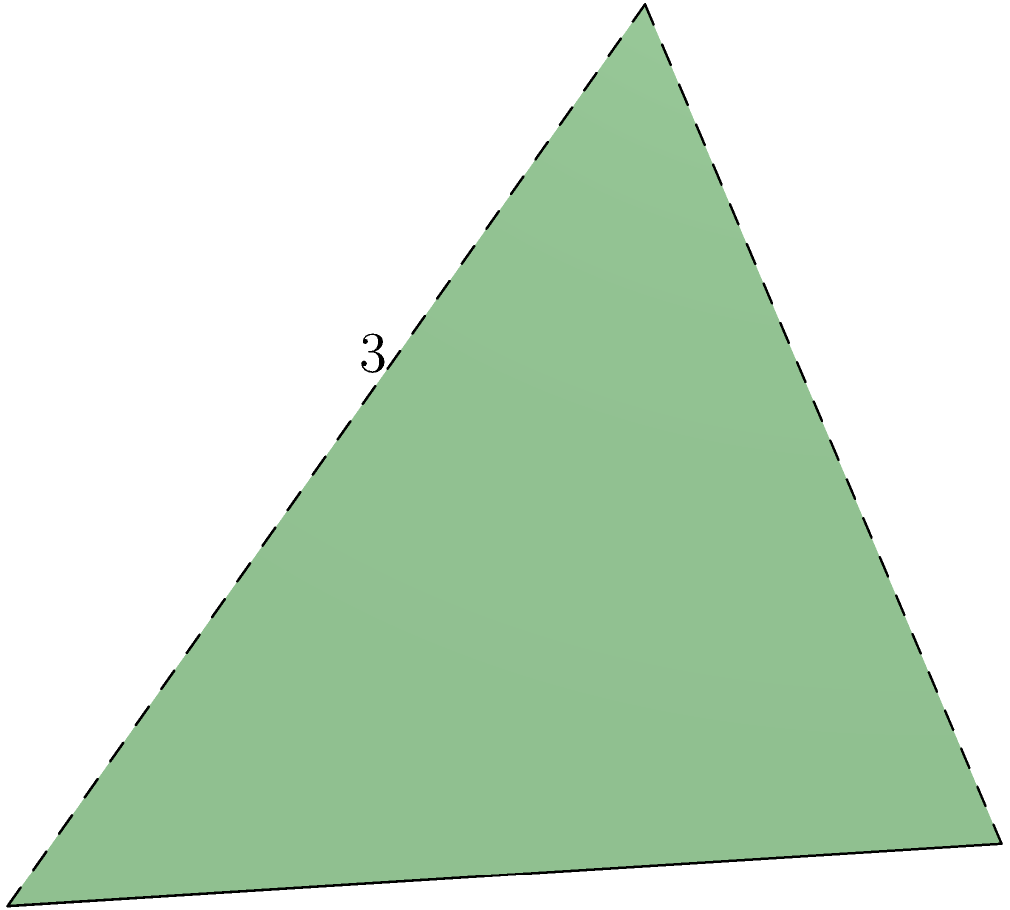You're exploring the wonders of ancient Egypt in your favorite strategy game when you come across a pyramid with a square base. The base measures 4 meters on each side, and the height of the pyramid is 3 meters. What is the volume of this pyramid? Let's approach this step-by-step:

1) The formula for the volume of a pyramid is:
   $$V = \frac{1}{3} \times B \times h$$
   where $V$ is volume, $B$ is the area of the base, and $h$ is the height.

2) We need to find the area of the base first. The base is a square with side length 4 meters:
   $$B = 4 \text{ m} \times 4 \text{ m} = 16 \text{ m}^2$$

3) Now we have all the information we need:
   - Base area $(B) = 16 \text{ m}^2$
   - Height $(h) = 3 \text{ m}$

4) Let's plug these into our formula:
   $$V = \frac{1}{3} \times 16 \text{ m}^2 \times 3 \text{ m}$$

5) Simplify:
   $$V = \frac{16 \times 3}{3} \text{ m}^3 = 16 \text{ m}^3$$

Therefore, the volume of the pyramid is 16 cubic meters.
Answer: 16 m³ 